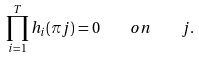<formula> <loc_0><loc_0><loc_500><loc_500>\prod _ { i = 1 } ^ { T } h _ { i } ( \pi j ) = 0 \quad o n \quad j .</formula> 